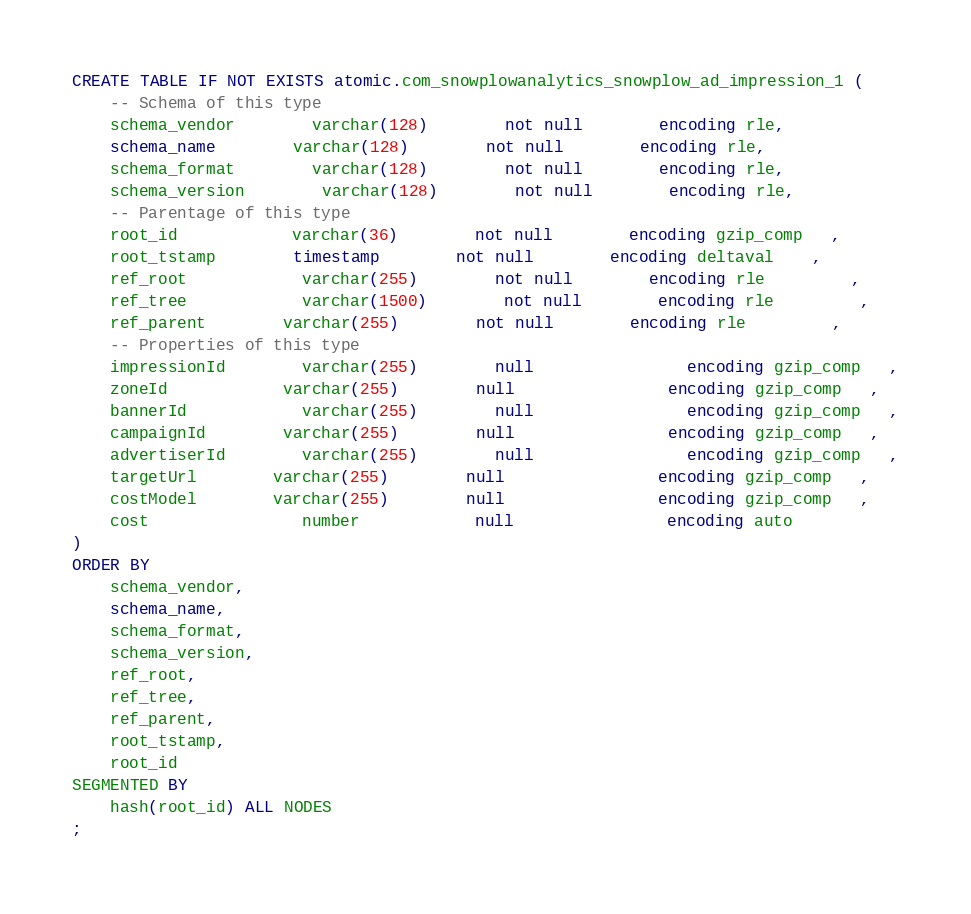Convert code to text. <code><loc_0><loc_0><loc_500><loc_500><_SQL_>CREATE TABLE IF NOT EXISTS atomic.com_snowplowanalytics_snowplow_ad_impression_1 (
	-- Schema of this type
	schema_vendor		varchar(128)		not null		encoding rle,
	schema_name 		varchar(128)		not null		encoding rle,
	schema_format		varchar(128)		not null		encoding rle,
	schema_version		varchar(128)		not null		encoding rle,
	-- Parentage of this type
	root_id     		varchar(36) 		not null		encoding gzip_comp   ,
	root_tstamp 		timestamp   		not null		encoding deltaval    ,
	ref_root    		varchar(255)		not null		encoding rle         ,
	ref_tree    		varchar(1500)		not null		encoding rle         ,
	ref_parent  		varchar(255)		not null		encoding rle         ,
	-- Properties of this type
	impressionId		varchar(255)		null        		encoding gzip_comp   ,
	zoneId      		varchar(255)		null        		encoding gzip_comp   ,
	bannerId    		varchar(255)		null        		encoding gzip_comp   ,
	campaignId  		varchar(255)		null        		encoding gzip_comp   ,
	advertiserId		varchar(255)		null        		encoding gzip_comp   ,
	targetUrl   		varchar(255)		null        		encoding gzip_comp   ,
	costModel   		varchar(255)		null        		encoding gzip_comp   ,
	cost        		number      		null        		encoding auto        
)
ORDER BY
	schema_vendor,
	schema_name,
	schema_format,
	schema_version,
	ref_root,
	ref_tree,
	ref_parent,
	root_tstamp,
	root_id
SEGMENTED BY
	hash(root_id) ALL NODES
;</code> 